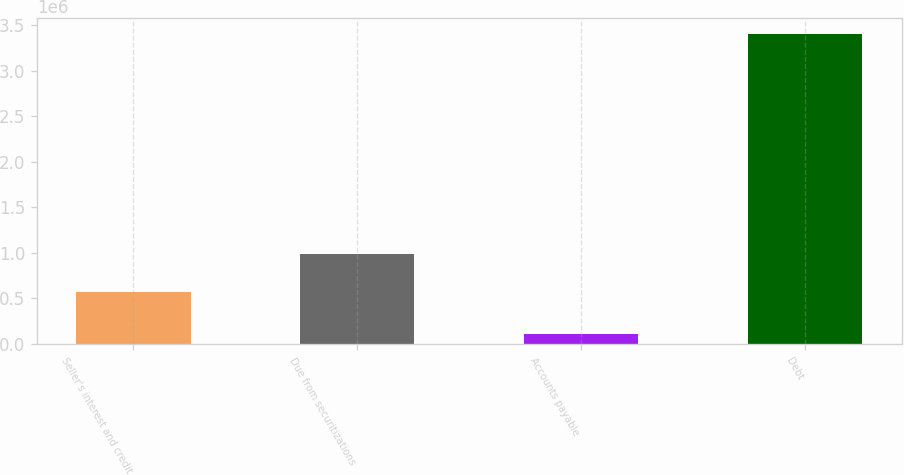Convert chart. <chart><loc_0><loc_0><loc_500><loc_500><bar_chart><fcel>Seller's interest and credit<fcel>Due from securitizations<fcel>Accounts payable<fcel>Debt<nl><fcel>574004<fcel>992523<fcel>103891<fcel>3.40804e+06<nl></chart> 